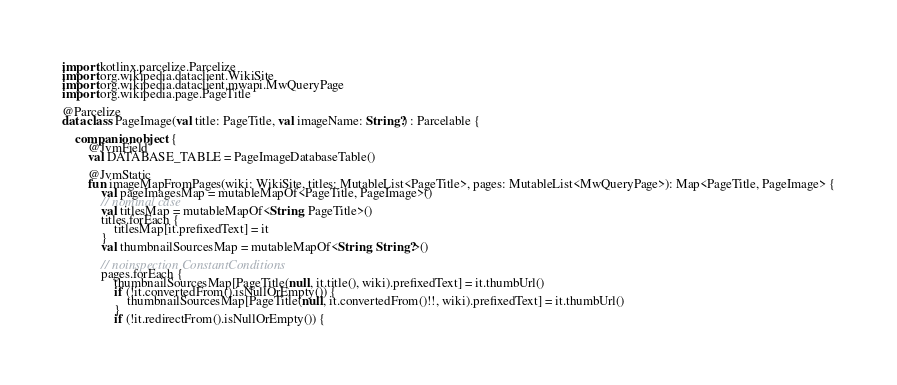Convert code to text. <code><loc_0><loc_0><loc_500><loc_500><_Kotlin_>import kotlinx.parcelize.Parcelize
import org.wikipedia.dataclient.WikiSite
import org.wikipedia.dataclient.mwapi.MwQueryPage
import org.wikipedia.page.PageTitle

@Parcelize
data class PageImage(val title: PageTitle, val imageName: String?) : Parcelable {

    companion object {
        @JvmField
        val DATABASE_TABLE = PageImageDatabaseTable()

        @JvmStatic
        fun imageMapFromPages(wiki: WikiSite, titles: MutableList<PageTitle>, pages: MutableList<MwQueryPage>): Map<PageTitle, PageImage> {
            val pageImagesMap = mutableMapOf<PageTitle, PageImage>()
            // nominal case
            val titlesMap = mutableMapOf<String, PageTitle>()
            titles.forEach {
                titlesMap[it.prefixedText] = it
            }
            val thumbnailSourcesMap = mutableMapOf<String, String?>()

            // noinspection ConstantConditions
            pages.forEach {
                thumbnailSourcesMap[PageTitle(null, it.title(), wiki).prefixedText] = it.thumbUrl()
                if (!it.convertedFrom().isNullOrEmpty()) {
                    thumbnailSourcesMap[PageTitle(null, it.convertedFrom()!!, wiki).prefixedText] = it.thumbUrl()
                }
                if (!it.redirectFrom().isNullOrEmpty()) {</code> 